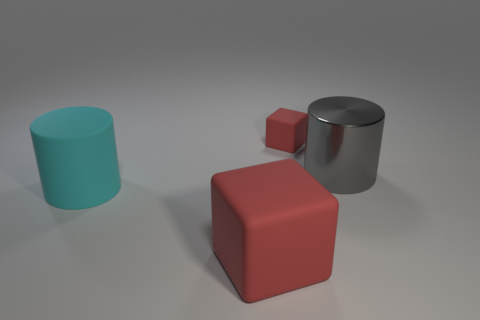Add 4 large blue matte objects. How many objects exist? 8 Add 1 red matte things. How many red matte things are left? 3 Add 1 tiny cubes. How many tiny cubes exist? 2 Subtract 0 red balls. How many objects are left? 4 Subtract all cyan objects. Subtract all large cylinders. How many objects are left? 1 